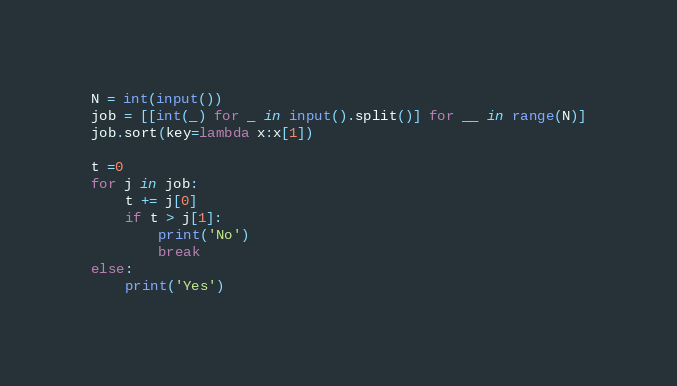Convert code to text. <code><loc_0><loc_0><loc_500><loc_500><_Python_>N = int(input())
job = [[int(_) for _ in input().split()] for __ in range(N)]
job.sort(key=lambda x:x[1])

t =0
for j in job:
    t += j[0]
    if t > j[1]:
        print('No')
        break
else:
    print('Yes')
</code> 